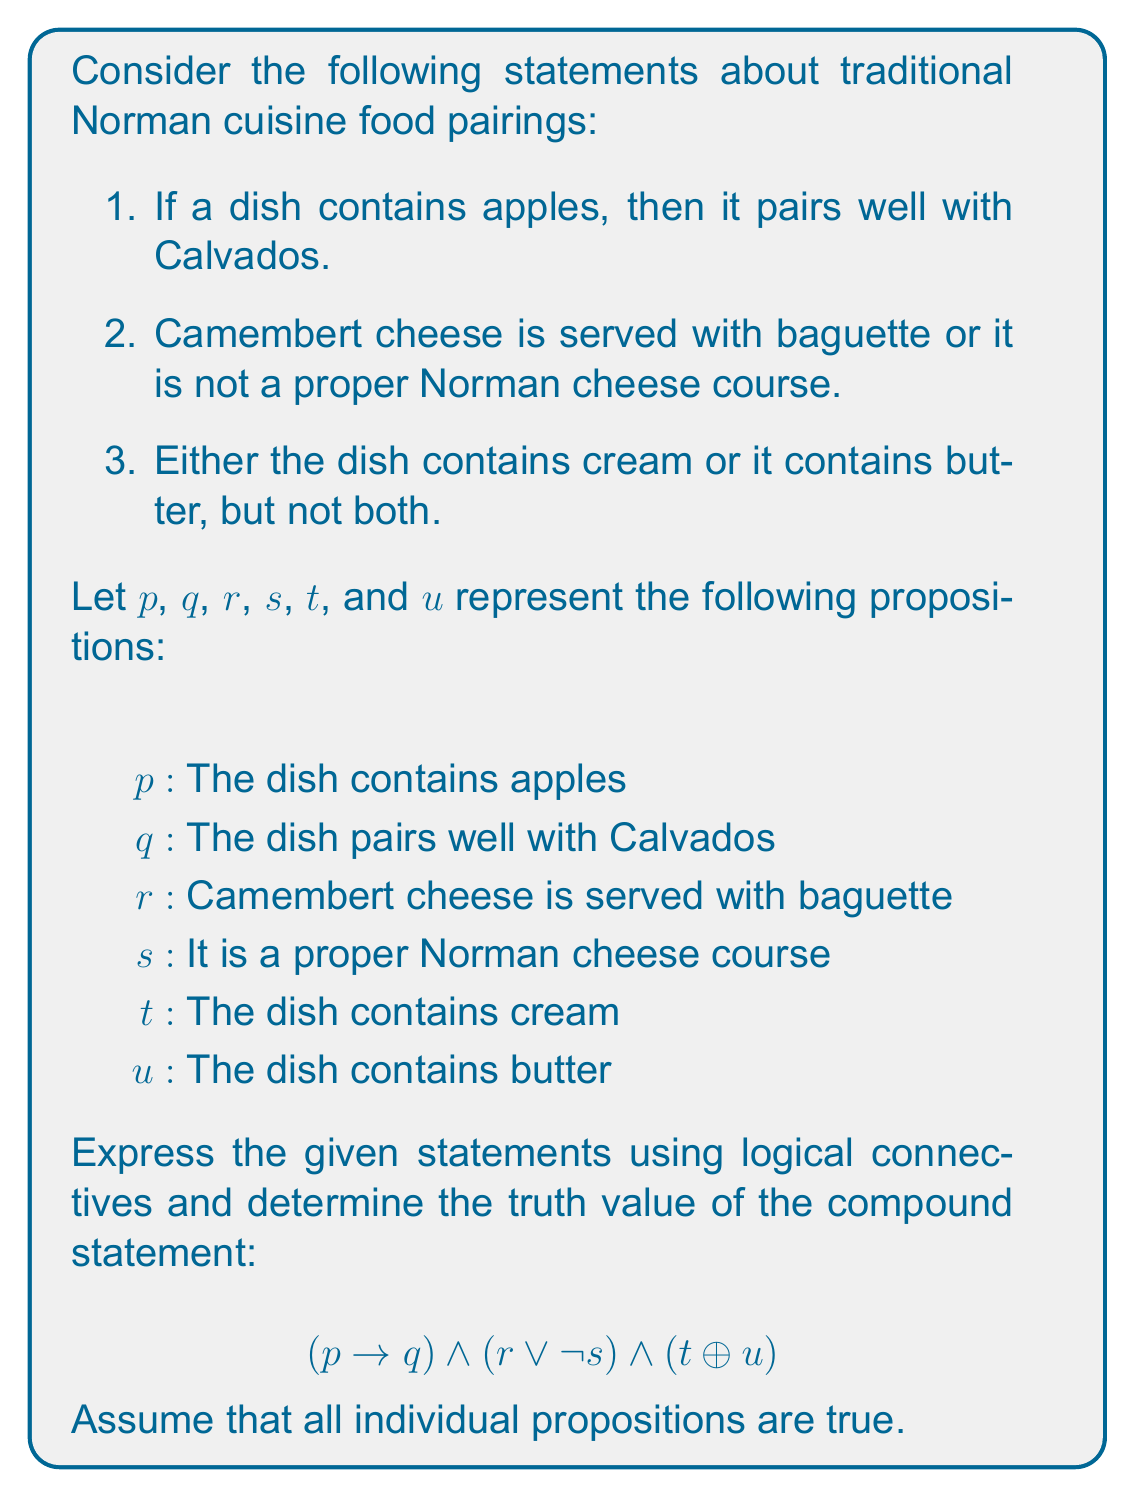Give your solution to this math problem. Let's analyze this compound statement step by step:

1. $(p \rightarrow q)$: This represents "If a dish contains apples, then it pairs well with Calvados." Since we assume all individual propositions are true, both $p$ and $q$ are true. For an implication, if both the antecedent and consequent are true, the entire implication is true. So, $(p \rightarrow q)$ is true.

2. $(r \lor \lnot s)$: This represents "Camembert cheese is served with baguette or it is not a proper Norman cheese course." Since $r$ is true (Camembert is served with baguette) and $s$ is also true (it is a proper Norman cheese course), we have:
   $(true \lor \lnot true) = (true \lor false) = true$

3. $(t \oplus u)$: This represents "Either the dish contains cream or it contains butter, but not both." The $\oplus$ symbol denotes exclusive OR. Since both $t$ and $u$ are assumed to be true, we have:
   $(true \oplus true) = false$

Now, let's combine these results using the AND ($\land$) operator:

$$(p \rightarrow q) \land (r \lor \lnot s) \land (t \oplus u)$$
$$(true) \land (true) \land (false)$$
$$= false$$

Therefore, the entire compound statement is false.
Answer: False 